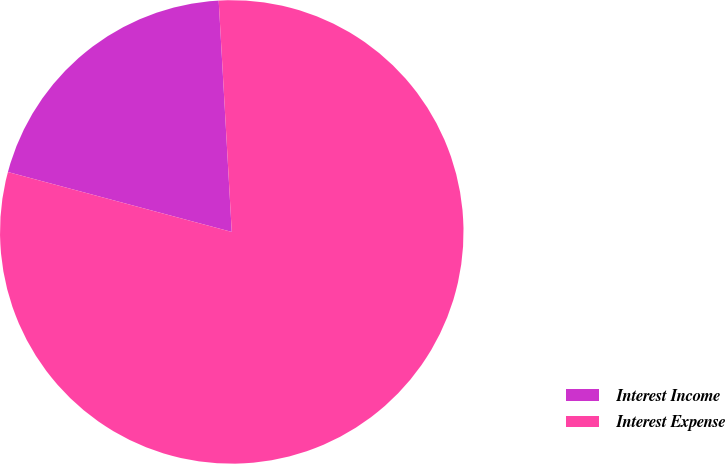Convert chart. <chart><loc_0><loc_0><loc_500><loc_500><pie_chart><fcel>Interest Income<fcel>Interest Expense<nl><fcel>19.94%<fcel>80.06%<nl></chart> 